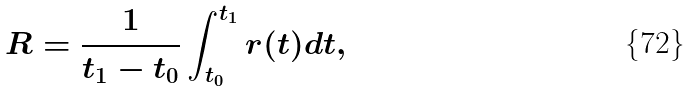Convert formula to latex. <formula><loc_0><loc_0><loc_500><loc_500>R = \frac { 1 } { t _ { 1 } - t _ { 0 } } \int _ { t _ { 0 } } ^ { t _ { 1 } } r ( t ) d t ,</formula> 